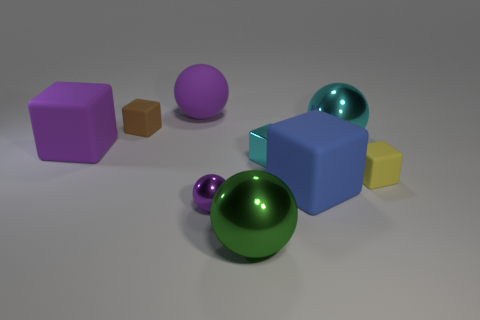What number of big cyan metallic things have the same shape as the small yellow matte object?
Ensure brevity in your answer.  0. Are there any purple blocks made of the same material as the big green sphere?
Provide a short and direct response. No. What material is the large cube right of the metallic ball to the left of the green metallic thing?
Provide a short and direct response. Rubber. There is a shiny ball that is to the right of the green ball; how big is it?
Provide a succinct answer. Large. Do the tiny ball and the large matte thing in front of the yellow block have the same color?
Ensure brevity in your answer.  No. Are there any metal objects of the same color as the tiny shiny cube?
Your response must be concise. Yes. Is the tiny yellow thing made of the same material as the large cube to the right of the big green sphere?
Give a very brief answer. Yes. What number of big objects are green balls or cyan shiny spheres?
Your response must be concise. 2. There is a cube that is the same color as the large rubber ball; what is its material?
Your answer should be compact. Rubber. Are there fewer things than big brown metal spheres?
Your answer should be compact. No. 